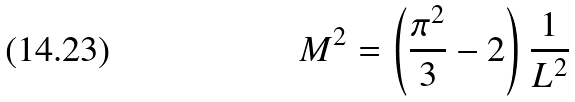<formula> <loc_0><loc_0><loc_500><loc_500>M ^ { 2 } = \left ( \frac { \pi ^ { 2 } } { 3 } - 2 \right ) \frac { 1 } { L ^ { 2 } }</formula> 